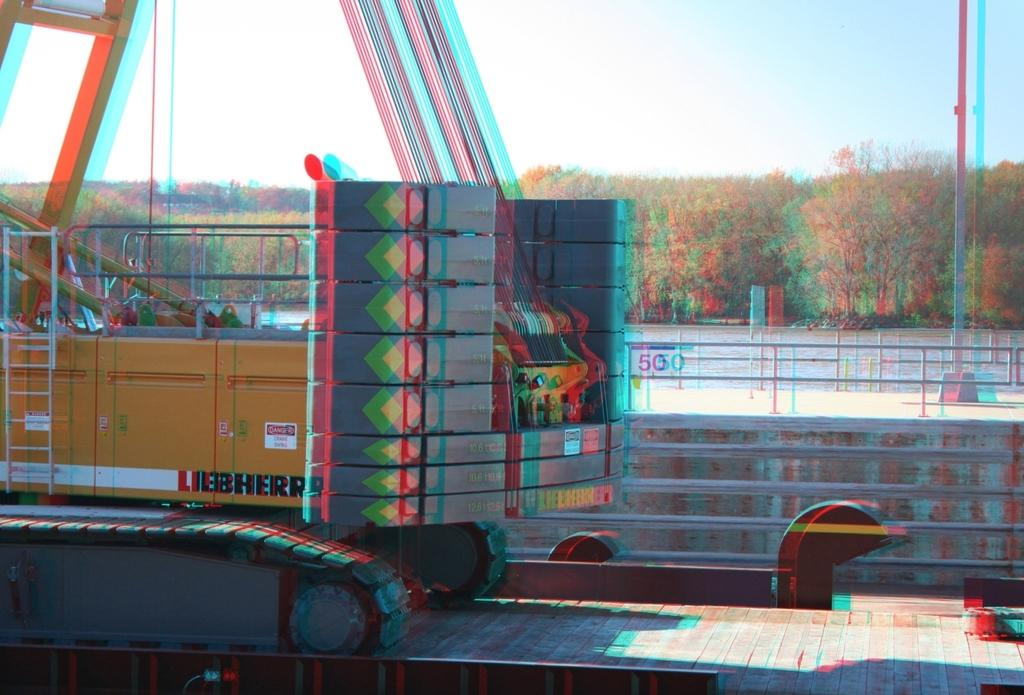What is the main subject of the image? There is a crane in the image. Can you describe the quality of the image? The image is blurry. What can be seen in the center of the image? There are trees in the center of the image. What is visible at the top of the image? The sky is visible at the top of the image. What color is the hair on the crane in the image? There is no hair present on the crane in the image, as cranes are birds and do not have hair. 